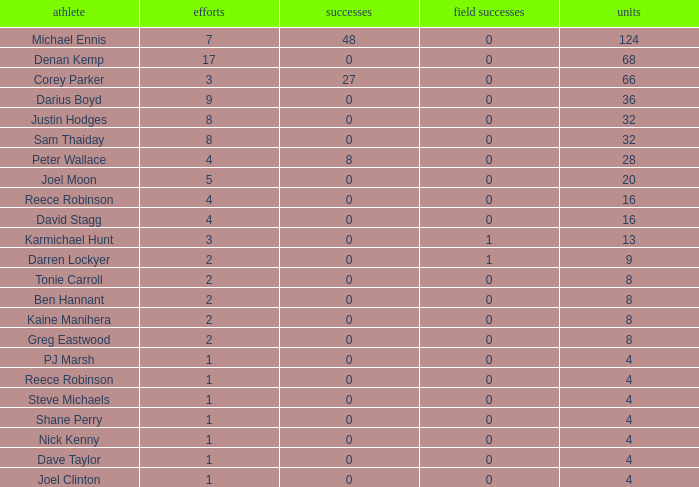How many points did the player with 2 tries and more than 0 field goals have? 9.0. Can you give me this table as a dict? {'header': ['athlete', 'efforts', 'successes', 'field successes', 'units'], 'rows': [['Michael Ennis', '7', '48', '0', '124'], ['Denan Kemp', '17', '0', '0', '68'], ['Corey Parker', '3', '27', '0', '66'], ['Darius Boyd', '9', '0', '0', '36'], ['Justin Hodges', '8', '0', '0', '32'], ['Sam Thaiday', '8', '0', '0', '32'], ['Peter Wallace', '4', '8', '0', '28'], ['Joel Moon', '5', '0', '0', '20'], ['Reece Robinson', '4', '0', '0', '16'], ['David Stagg', '4', '0', '0', '16'], ['Karmichael Hunt', '3', '0', '1', '13'], ['Darren Lockyer', '2', '0', '1', '9'], ['Tonie Carroll', '2', '0', '0', '8'], ['Ben Hannant', '2', '0', '0', '8'], ['Kaine Manihera', '2', '0', '0', '8'], ['Greg Eastwood', '2', '0', '0', '8'], ['PJ Marsh', '1', '0', '0', '4'], ['Reece Robinson', '1', '0', '0', '4'], ['Steve Michaels', '1', '0', '0', '4'], ['Shane Perry', '1', '0', '0', '4'], ['Nick Kenny', '1', '0', '0', '4'], ['Dave Taylor', '1', '0', '0', '4'], ['Joel Clinton', '1', '0', '0', '4']]} 